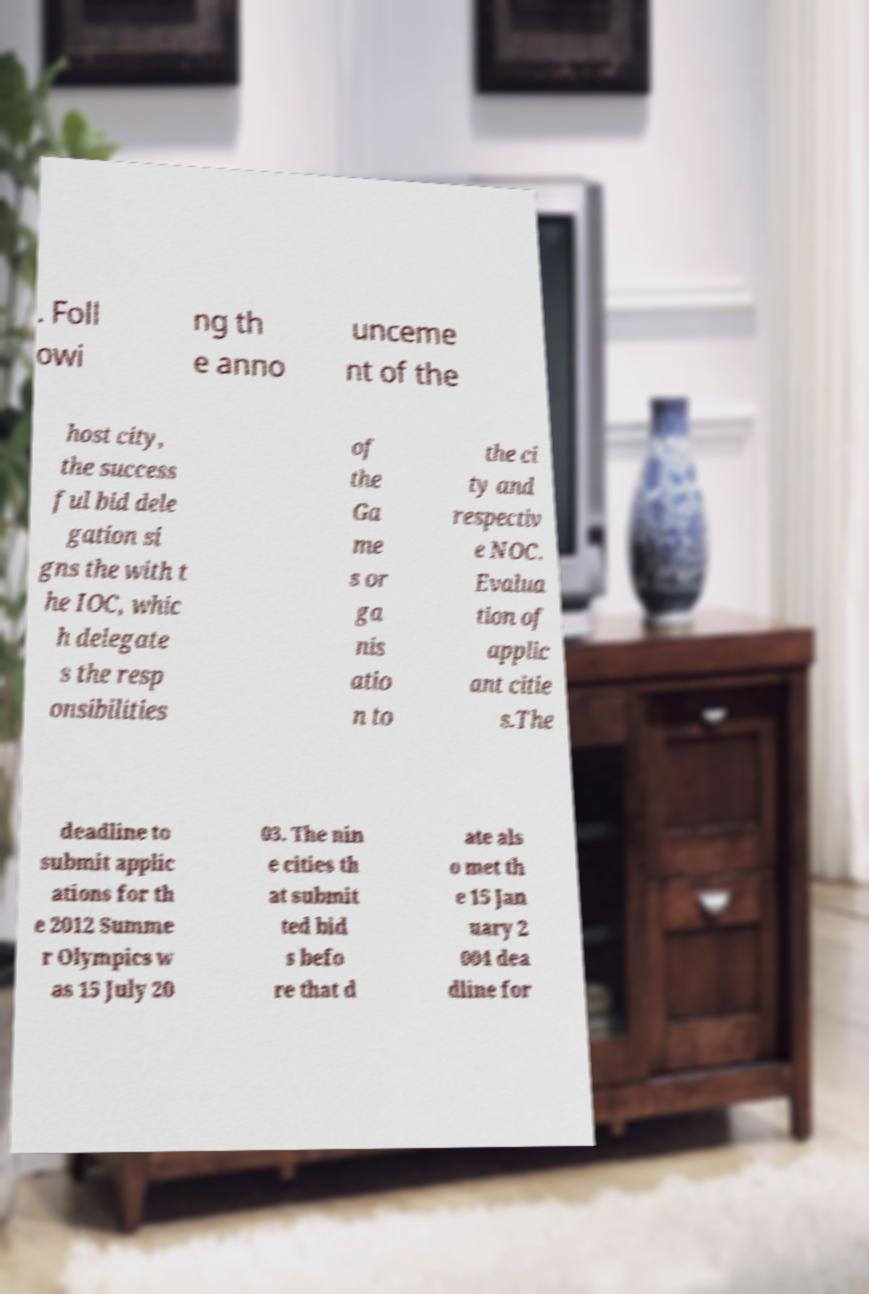Could you extract and type out the text from this image? . Foll owi ng th e anno unceme nt of the host city, the success ful bid dele gation si gns the with t he IOC, whic h delegate s the resp onsibilities of the Ga me s or ga nis atio n to the ci ty and respectiv e NOC. Evalua tion of applic ant citie s.The deadline to submit applic ations for th e 2012 Summe r Olympics w as 15 July 20 03. The nin e cities th at submit ted bid s befo re that d ate als o met th e 15 Jan uary 2 004 dea dline for 